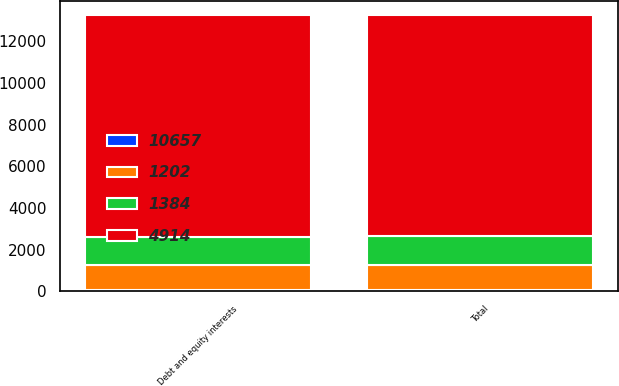Convert chart to OTSL. <chart><loc_0><loc_0><loc_500><loc_500><stacked_bar_chart><ecel><fcel>Debt and equity interests<fcel>Total<nl><fcel>4914<fcel>10657<fcel>10657<nl><fcel>1384<fcel>1384<fcel>1384<nl><fcel>10657<fcel>43<fcel>48<nl><fcel>1202<fcel>1202<fcel>1202<nl></chart> 